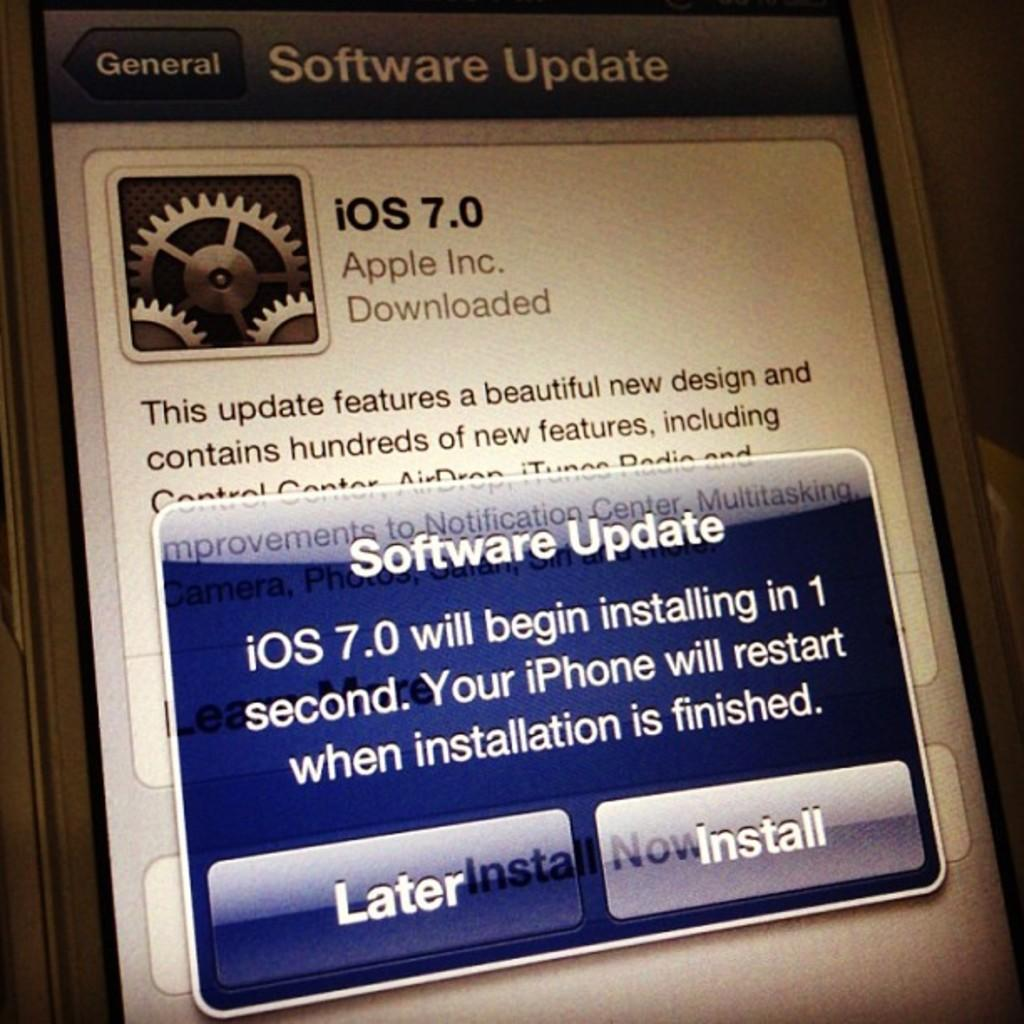<image>
Provide a brief description of the given image. Phone screen pushing a Software Update for iOS. 